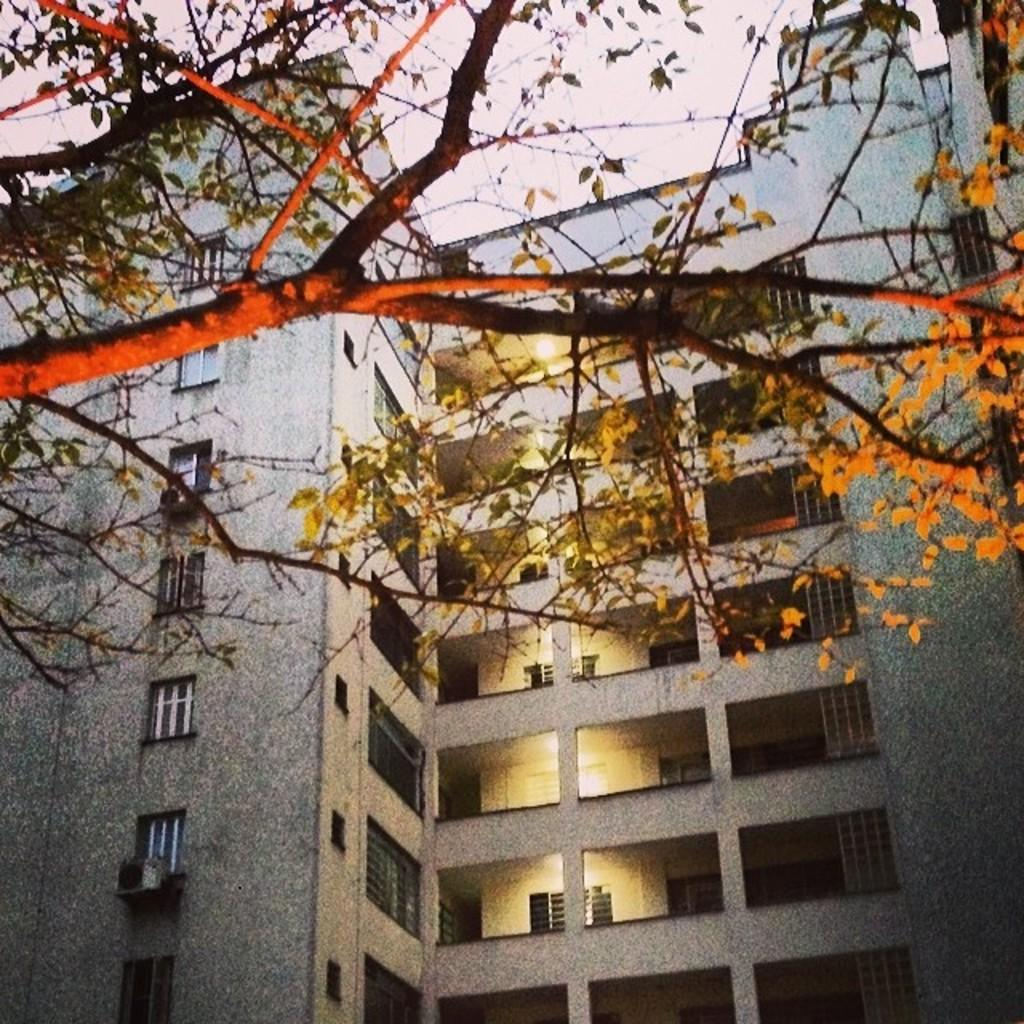What type of natural element is present in the image? There are branches of a tree in the image. What type of structure can be seen in the image? There is a building with pillars, windows, and lights in the image. What is visible at the top of the image? The sky is visible at the top of the image. How many crackers are hanging from the branches of the tree in the image? There are no crackers present in the image; it features branches of a tree and a building. What type of sail is visible on the building in the image? There is no sail present in the image; it features a building with pillars, windows, and lights. 